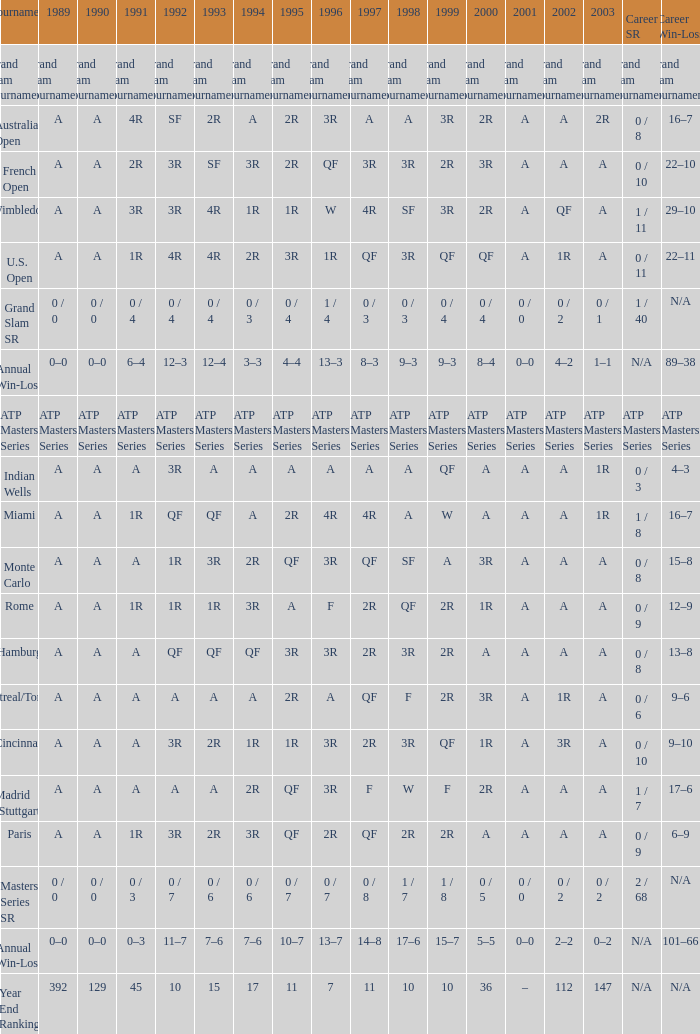What was the career sr value of a in 1980 and f in 1997? 1 / 7. 